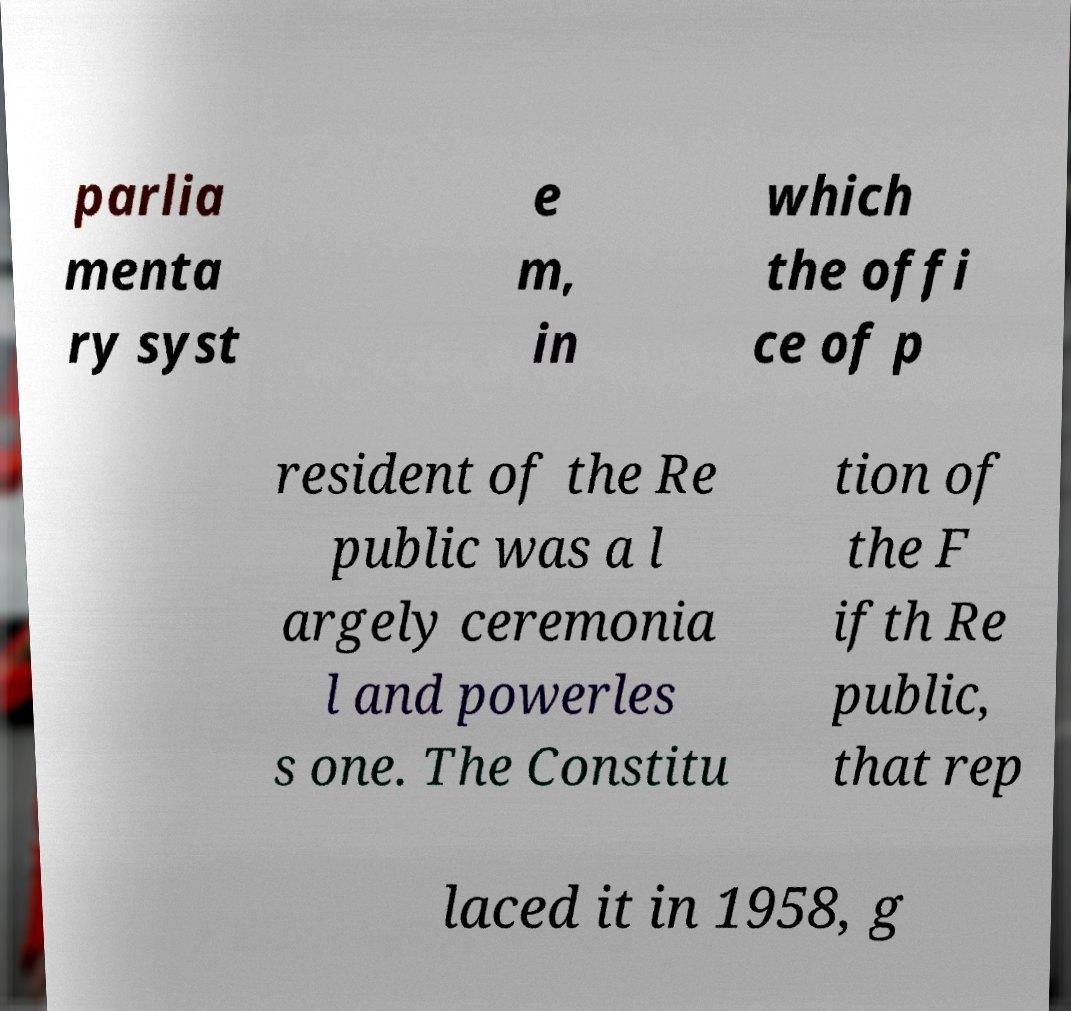For documentation purposes, I need the text within this image transcribed. Could you provide that? parlia menta ry syst e m, in which the offi ce of p resident of the Re public was a l argely ceremonia l and powerles s one. The Constitu tion of the F ifth Re public, that rep laced it in 1958, g 